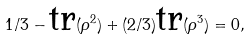<formula> <loc_0><loc_0><loc_500><loc_500>1 / 3 - \text {tr} ( \rho ^ { 2 } ) + ( 2 / 3 ) \text {tr} ( \rho ^ { 3 } ) = 0 ,</formula> 